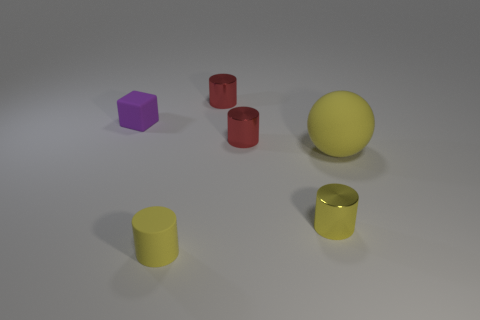What is the shape of the tiny shiny thing that is the same color as the small rubber cylinder?
Make the answer very short. Cylinder. Is there anything else that has the same size as the yellow ball?
Your answer should be very brief. No. What is the size of the matte thing that is to the left of the yellow sphere and behind the small yellow shiny object?
Make the answer very short. Small. What is the color of the rubber object that is the same shape as the yellow shiny thing?
Ensure brevity in your answer.  Yellow. What color is the object that is on the left side of the rubber thing that is in front of the rubber sphere?
Your answer should be very brief. Purple. What is the shape of the purple object?
Make the answer very short. Cube. What is the shape of the object that is in front of the purple thing and behind the big yellow object?
Your answer should be very brief. Cylinder. The small object that is made of the same material as the cube is what color?
Provide a succinct answer. Yellow. There is a tiny yellow object to the right of the tiny red metallic object that is behind the small matte object left of the matte cylinder; what is its shape?
Give a very brief answer. Cylinder. What is the size of the purple matte cube?
Your answer should be compact. Small. 